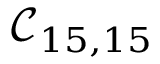<formula> <loc_0><loc_0><loc_500><loc_500>\mathcal { C } _ { 1 5 , 1 5 }</formula> 